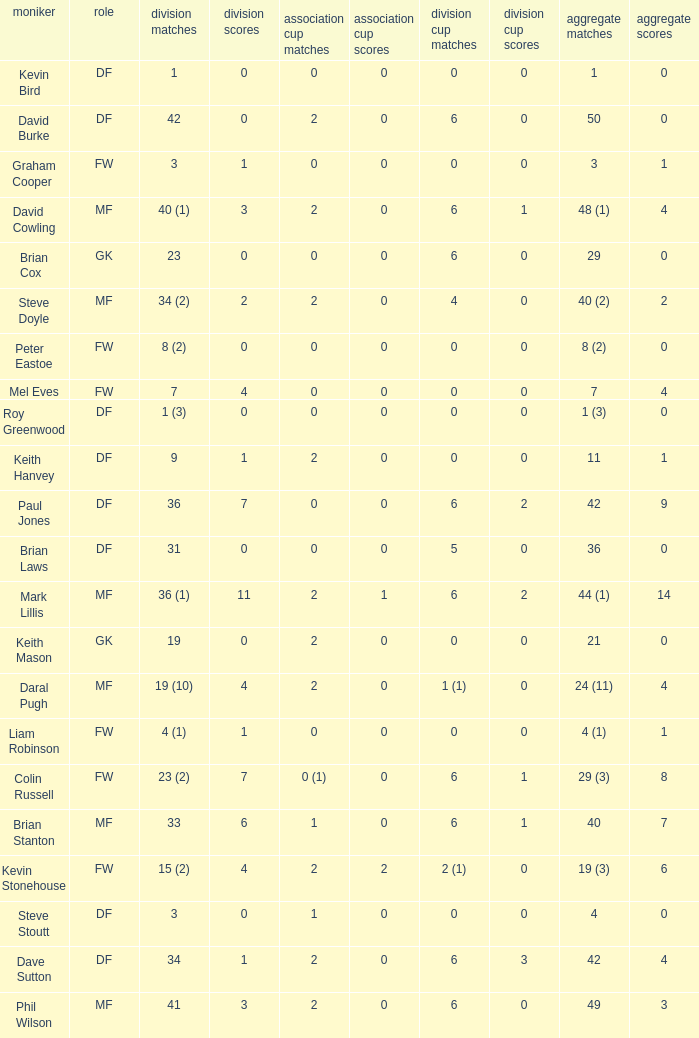What is the most total goals for a player having 0 FA Cup goals and 41 League appearances? 3.0. 